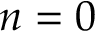<formula> <loc_0><loc_0><loc_500><loc_500>n = 0</formula> 